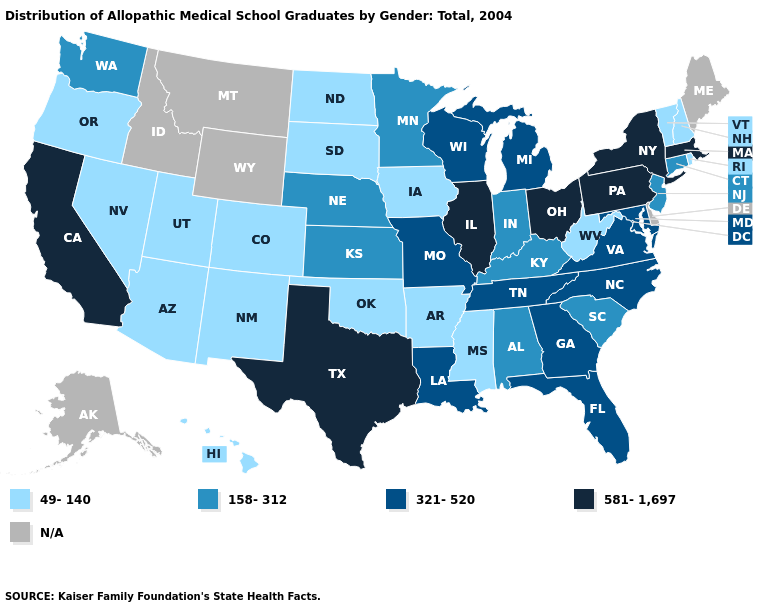Does the map have missing data?
Write a very short answer. Yes. Does Oklahoma have the lowest value in the South?
Be succinct. Yes. What is the highest value in states that border Kansas?
Give a very brief answer. 321-520. What is the lowest value in the West?
Concise answer only. 49-140. Among the states that border Vermont , does New Hampshire have the highest value?
Short answer required. No. Does the map have missing data?
Write a very short answer. Yes. Is the legend a continuous bar?
Answer briefly. No. Name the states that have a value in the range 581-1,697?
Concise answer only. California, Illinois, Massachusetts, New York, Ohio, Pennsylvania, Texas. Does the map have missing data?
Give a very brief answer. Yes. Does the map have missing data?
Give a very brief answer. Yes. Name the states that have a value in the range 581-1,697?
Concise answer only. California, Illinois, Massachusetts, New York, Ohio, Pennsylvania, Texas. What is the value of Maryland?
Be succinct. 321-520. Name the states that have a value in the range N/A?
Answer briefly. Alaska, Delaware, Idaho, Maine, Montana, Wyoming. What is the value of West Virginia?
Give a very brief answer. 49-140. 